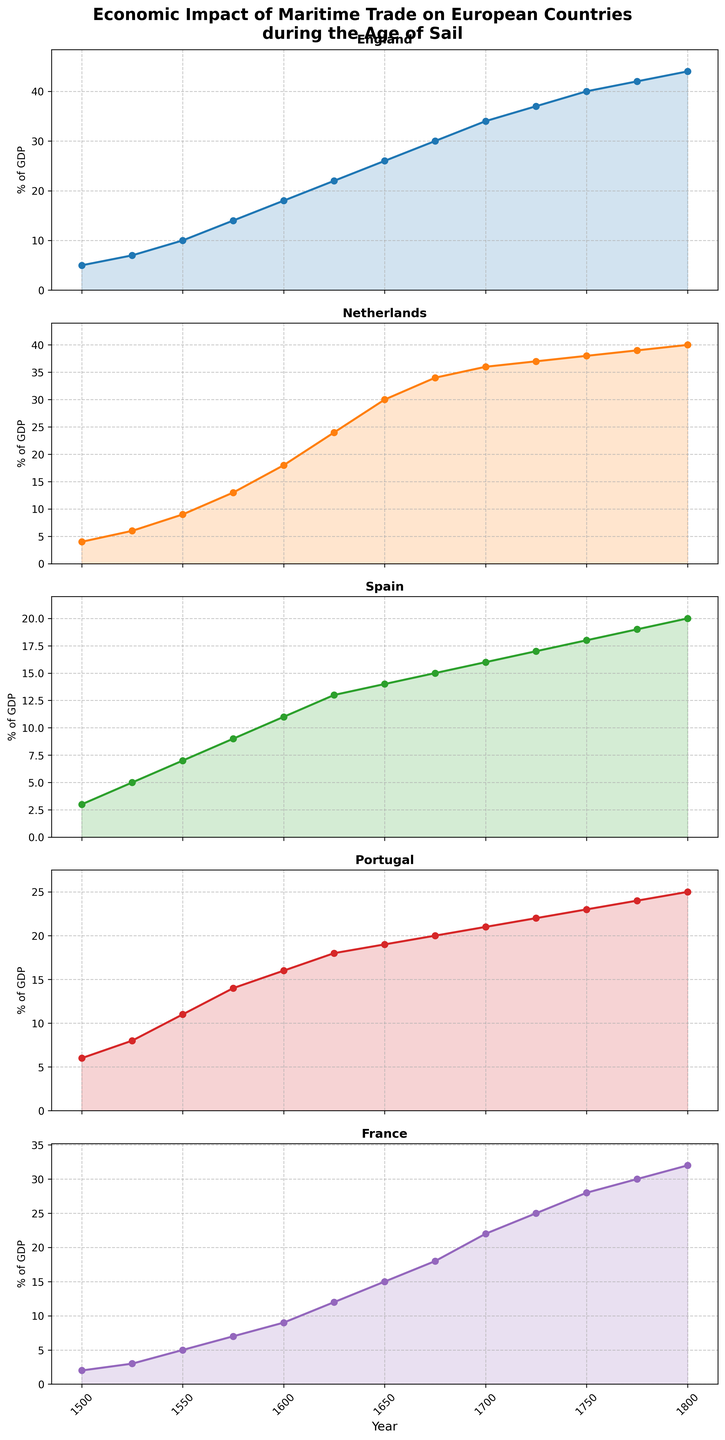Which country had the highest percentage of GDP from maritime trade in 1800? By looking at the height of the lines in 1800, we can see that England had the highest percentage of GDP from maritime trade among the countries.
Answer: England In which year did Portugal experience a significant increase in maritime trade's impact on GDP? By analyzing the graph of Portugal, we can see that there is a notable increase between 1500 and 1525, where its GDP percentage surged from 6 to 8.
Answer: 1525 Compare the trends of England and France from 1500 to 1800. Which country had a consistently higher GDP percentage from maritime trade? Observing the graphs of both England and France from 1500 to 1800, England's line is consistently above France's. This shows England had a consistently higher GDP percentage from maritime trade throughout this period.
Answer: England What is the average percentage of GDP from maritime trade for Spain between 1600 and 1800? To find the average, we sum the percentages from 1600 to 1800 (11 + 13 + 14 + 15 + 16 + 17 + 18 + 19 + 20) = 143 and divide by the number of data points (9). The average is 143/9.
Answer: 15.89 Identify the periods where the Netherlands experienced the greatest rate of increase in maritime trade's impact on GDP. By observing the slope of the graphs, the Netherlands had the greatest increase between 1600 and 1625 (18 to 24) and 1625 to 1650 (24 to 30).
Answer: 1600-1625 and 1625-1650 In 1750, what is the difference in GDP percentage from maritime trade between England and Portugal? By checking the values for England and Portugal in 1750, we see England at 40 and Portugal at 23. The difference is 40 - 23.
Answer: 17 During which decade did France surpass 20% of its GDP from maritime trade? Observing the graph, France surpassed 20% of GDP from maritime trade around the 1700s. Specifically, in 1700, it was already at 22%.
Answer: 1700s Compare the impact of maritime trade on GDP between the Netherlands and Spain in 1675. In 1675, the percentage for the Netherlands was 34, while for Spain, it was 15. The Netherlands had a significantly higher impact on GDP from maritime trade compared to Spain.
Answer: Netherlands What is the trend observed in all five countries' GDP percentages due to maritime trade from 1500 to 1800? All five countries show an increasing trend in GDP percentages due to maritime trade over the period, though the rates of increase differ among countries.
Answer: Increasing trend 